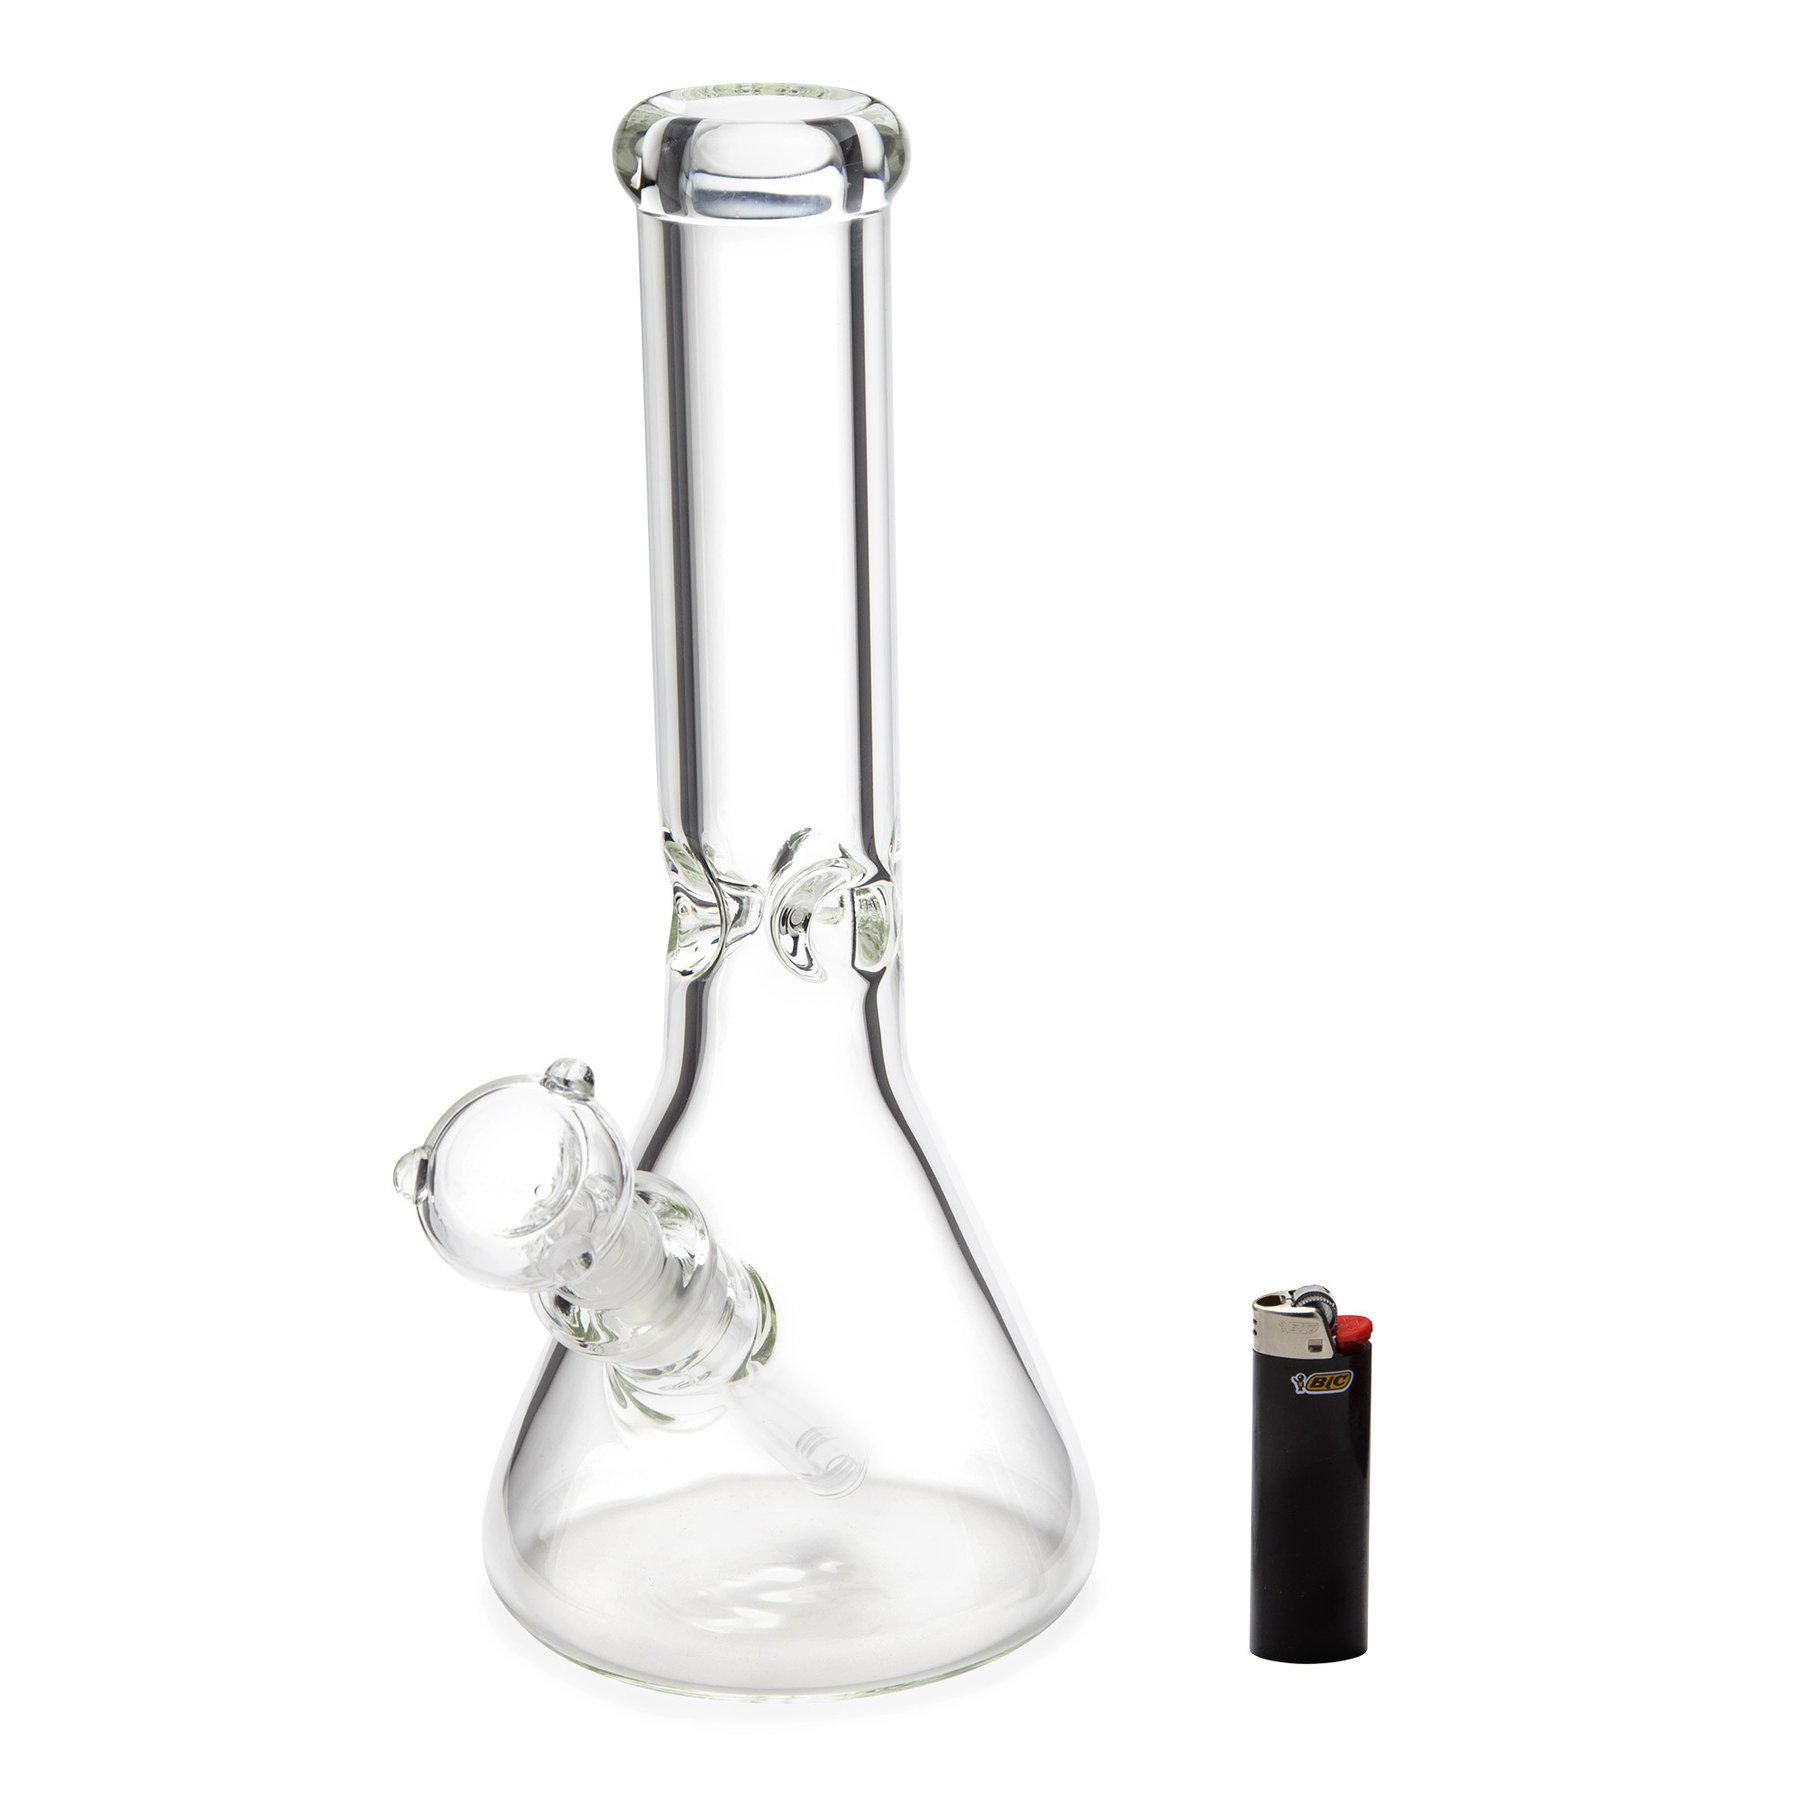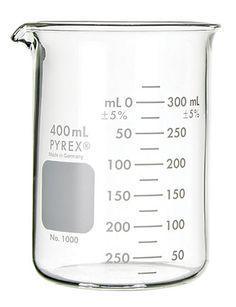The first image is the image on the left, the second image is the image on the right. Evaluate the accuracy of this statement regarding the images: "Right image contains a single empty glass vessel shaped like a cylinder with a small pour spout on one side.". Is it true? Answer yes or no. Yes. The first image is the image on the left, the second image is the image on the right. Assess this claim about the two images: "There are two flasks in the pair of images.". Correct or not? Answer yes or no. Yes. 